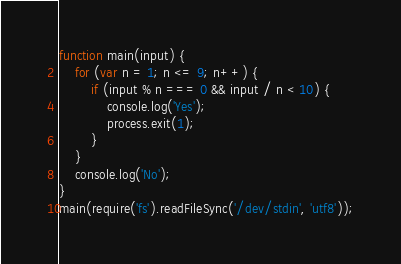<code> <loc_0><loc_0><loc_500><loc_500><_JavaScript_>function main(input) {
    for (var n = 1; n <= 9; n++) {
        if (input % n === 0 && input / n < 10) {
            console.log('Yes');
            process.exit(1);
        }
    }
    console.log('No');
}
main(require('fs').readFileSync('/dev/stdin', 'utf8'));</code> 